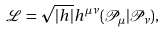Convert formula to latex. <formula><loc_0><loc_0><loc_500><loc_500>\mathcal { L } = \sqrt { | h | } h ^ { \mu \nu } ( \mathcal { P } _ { \mu } | \mathcal { P } _ { \nu } ) ,</formula> 